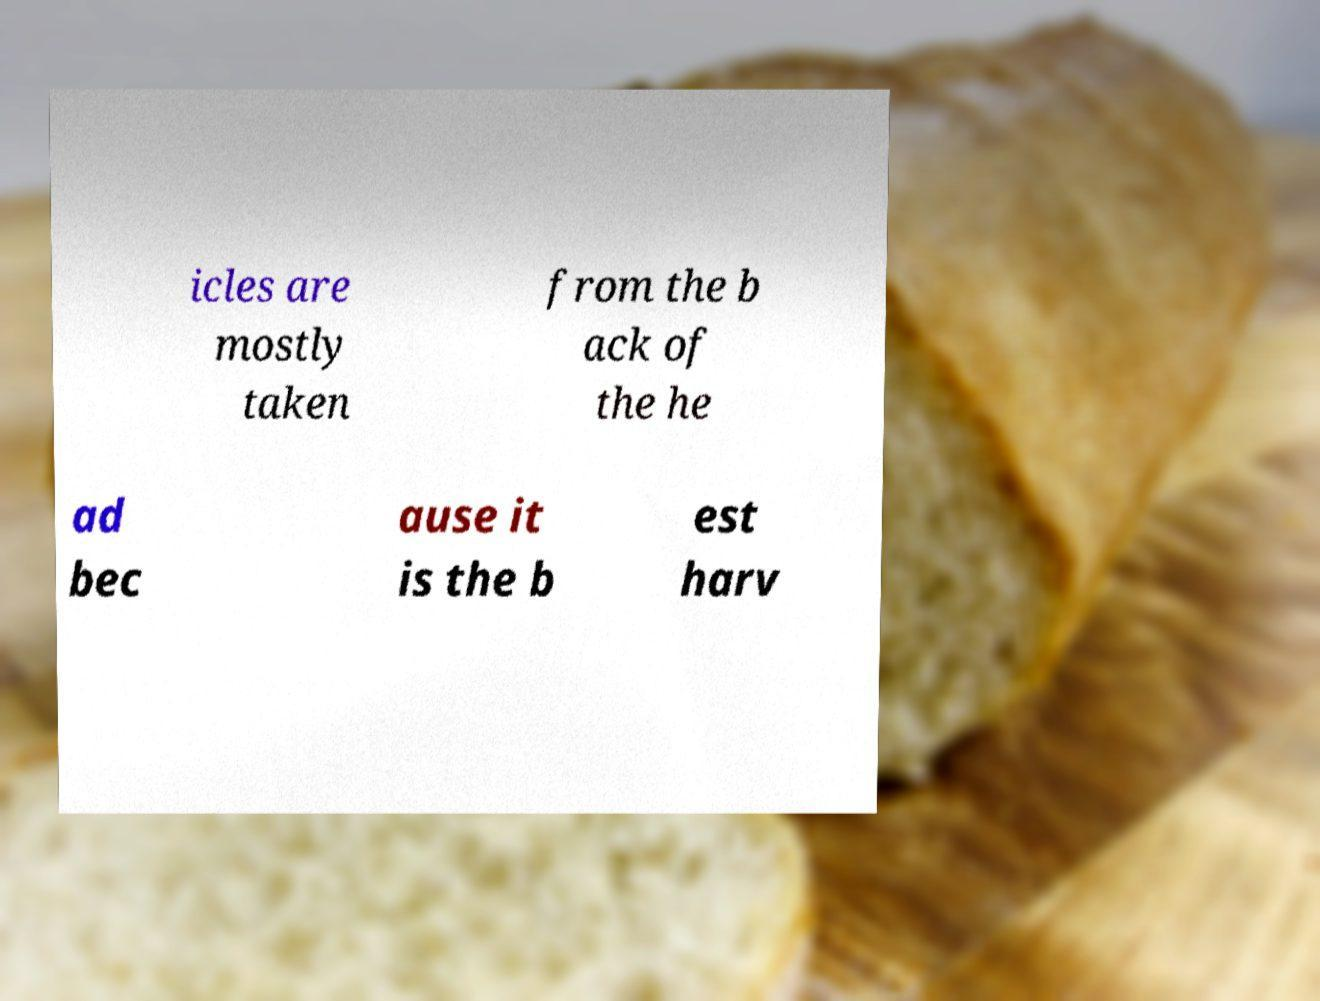For documentation purposes, I need the text within this image transcribed. Could you provide that? icles are mostly taken from the b ack of the he ad bec ause it is the b est harv 